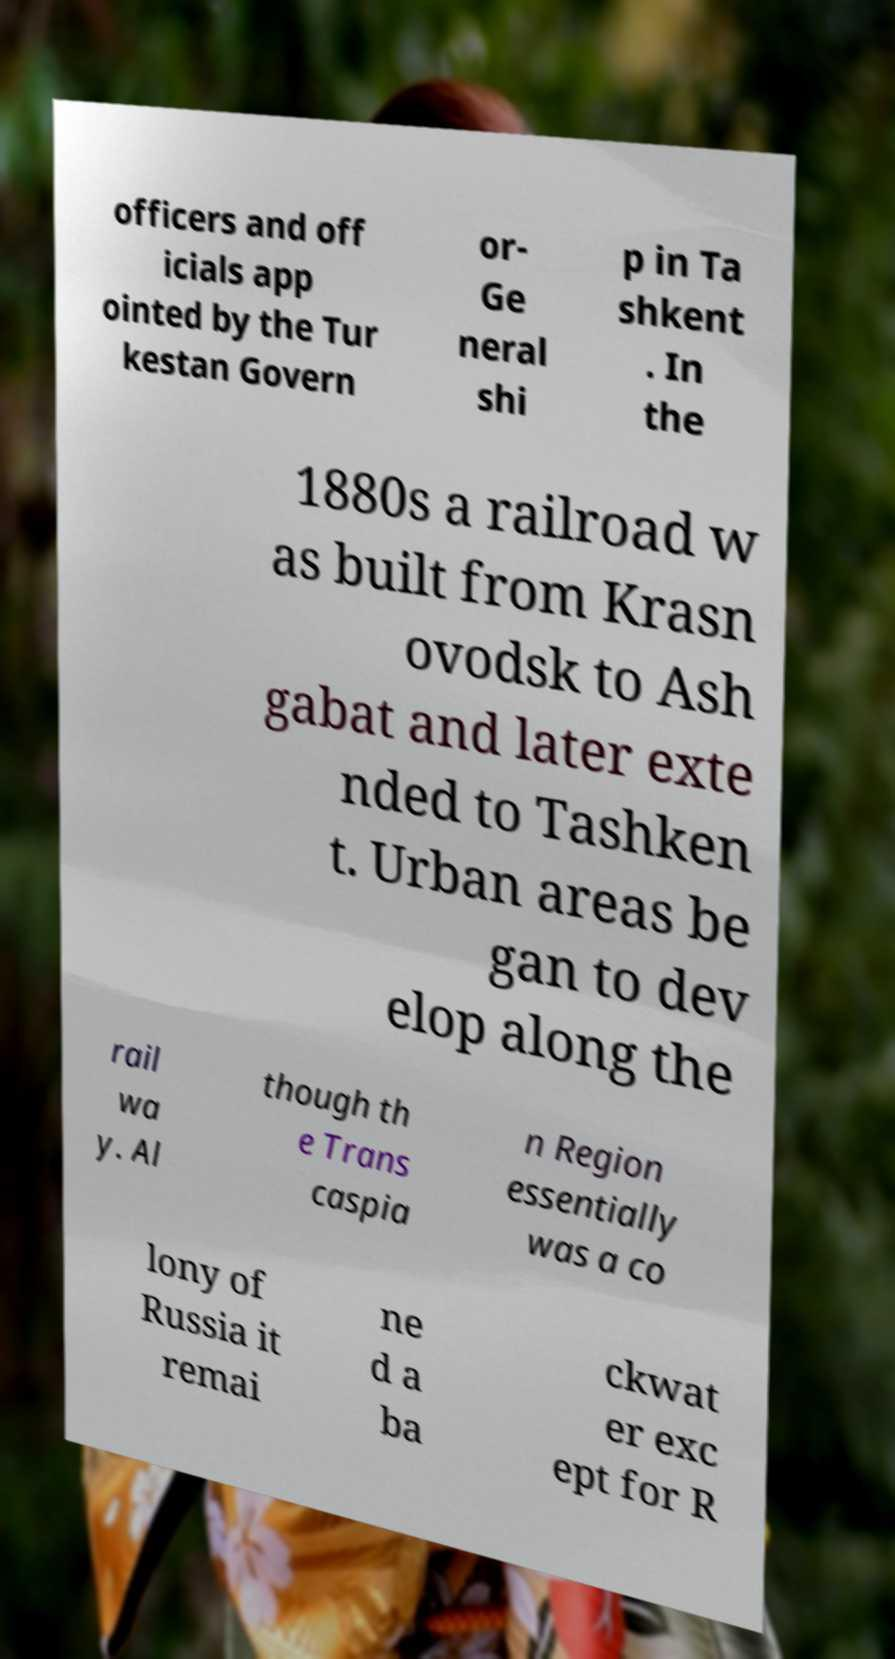Please read and relay the text visible in this image. What does it say? officers and off icials app ointed by the Tur kestan Govern or- Ge neral shi p in Ta shkent . In the 1880s a railroad w as built from Krasn ovodsk to Ash gabat and later exte nded to Tashken t. Urban areas be gan to dev elop along the rail wa y. Al though th e Trans caspia n Region essentially was a co lony of Russia it remai ne d a ba ckwat er exc ept for R 